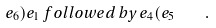<formula> <loc_0><loc_0><loc_500><loc_500>e _ { 6 } ) e _ { 1 } \, f o l l o w e d \, b y \, e _ { 4 } ( e _ { 5 } \quad .</formula> 